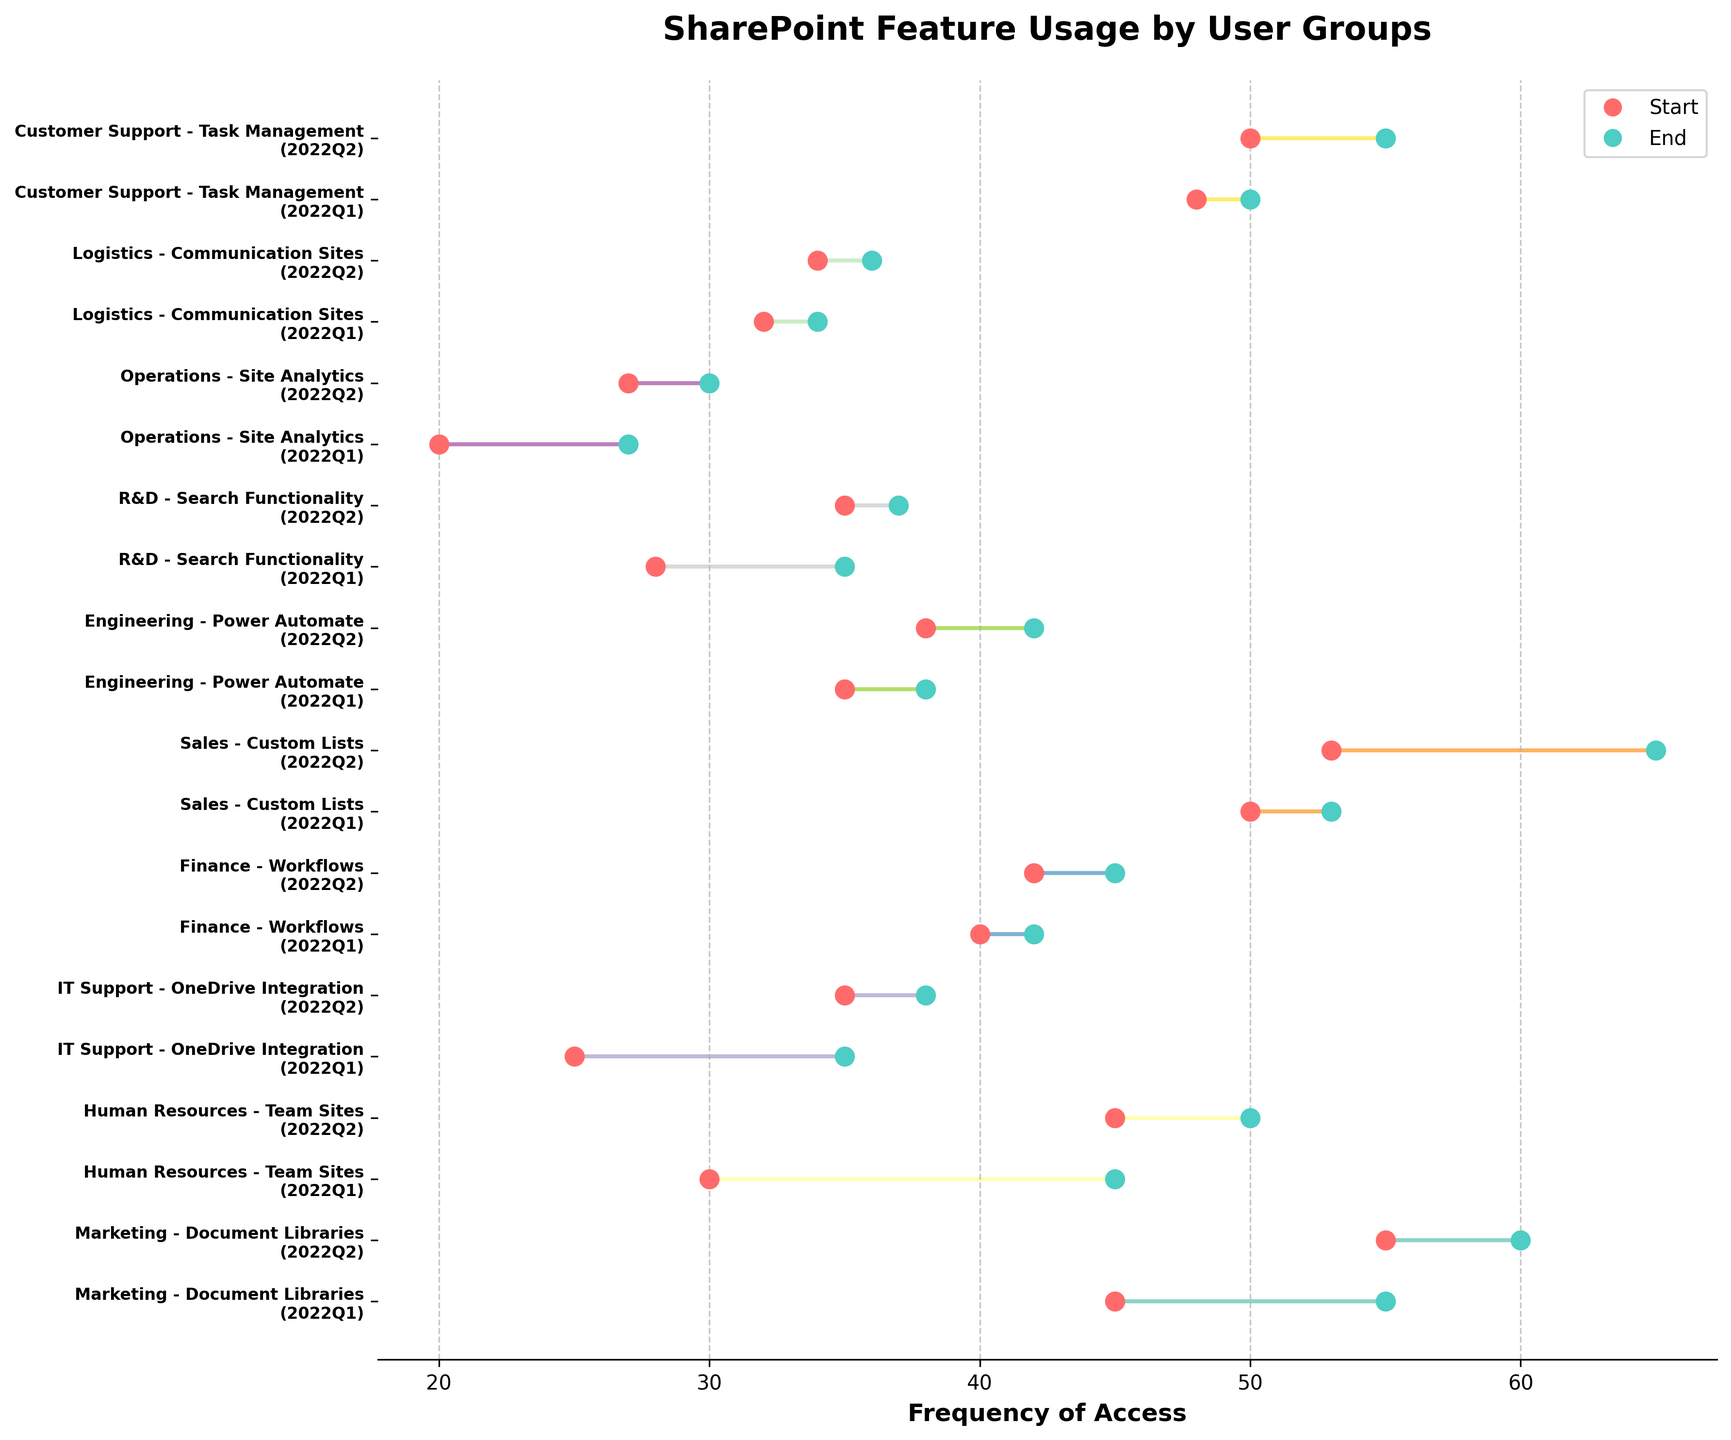Which user group shows the highest increase in the frequency of access from Q1 to Q2 in its feature? To determine which user group shows the highest increase, we need to calculate the difference between the StartFrequency and EndFrequency for each entry and then compare them. Sales (Custom Lists) shows an increase from 50 to 65, which is an increase of 15, the highest among all groups.
Answer: Sales What is the total frequency increase across all user groups for "Team Sites"? First, identify the entries corresponding to "Team Sites" which is "Human Resources". For 2022Q1 it's from 30 to 45 (increase of 15) and from 45 to 50 in 2022Q2 (increase of 5). Summing these values gives 20.
Answer: 20 Which feature has the smallest change in access frequency? Review the difference between StartFrequency and EndFrequency for all features. "Communication Sites" (Logistics) shows changes of 2 in Q1 and Q2, which is the smallest change.
Answer: Communication Sites How many user groups are represented in the dumbbell plot? Each y-tick label on the plot represents a unique user group and there are a total of 10 y-tick labels, hence 10 user groups.
Answer: 10 Which user group has the highest end frequency for its feature in Q2? To find this, look at the EndFrequency values for all user groups in Q2. Sales (Custom Lists) with an EndFrequency of 65 has the highest value.
Answer: Sales 